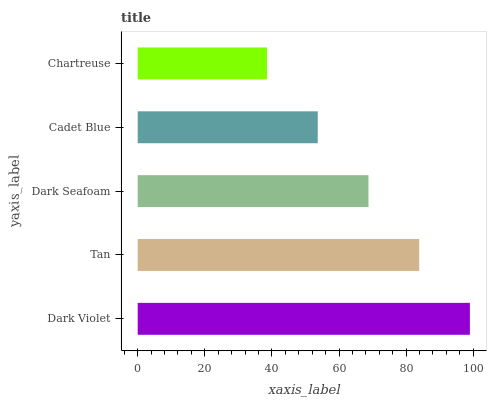Is Chartreuse the minimum?
Answer yes or no. Yes. Is Dark Violet the maximum?
Answer yes or no. Yes. Is Tan the minimum?
Answer yes or no. No. Is Tan the maximum?
Answer yes or no. No. Is Dark Violet greater than Tan?
Answer yes or no. Yes. Is Tan less than Dark Violet?
Answer yes or no. Yes. Is Tan greater than Dark Violet?
Answer yes or no. No. Is Dark Violet less than Tan?
Answer yes or no. No. Is Dark Seafoam the high median?
Answer yes or no. Yes. Is Dark Seafoam the low median?
Answer yes or no. Yes. Is Cadet Blue the high median?
Answer yes or no. No. Is Chartreuse the low median?
Answer yes or no. No. 